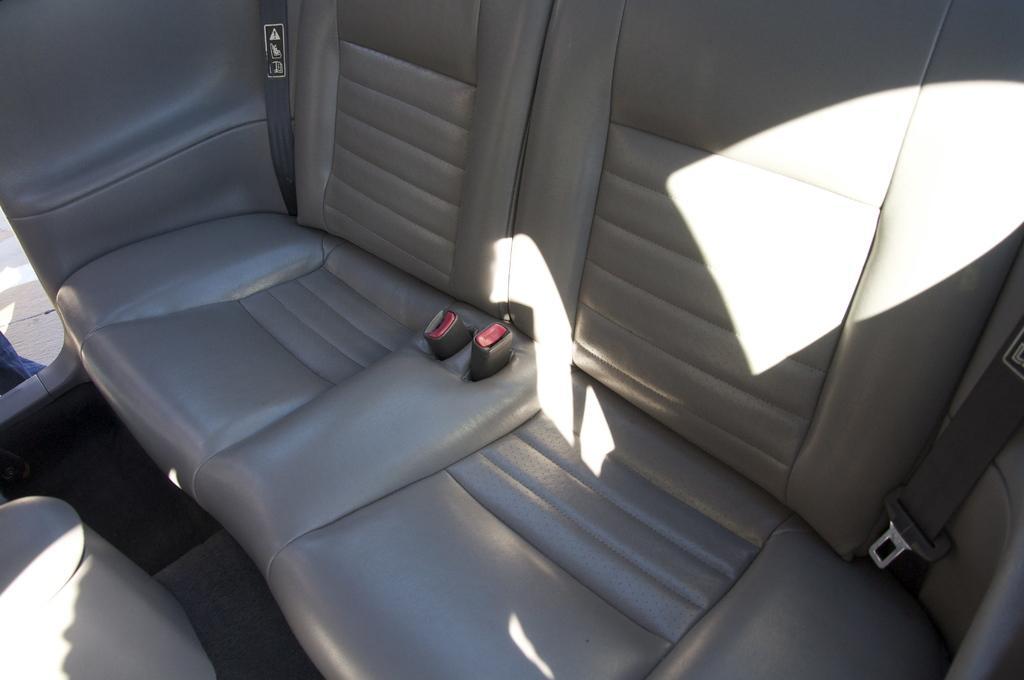Please provide a concise description of this image. This image is a zoom in picture of cars seats as we can see in middle of this image. 